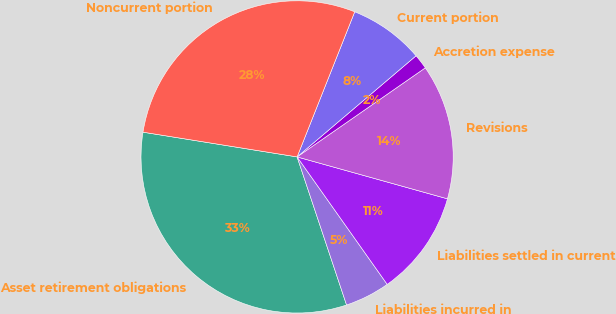Convert chart to OTSL. <chart><loc_0><loc_0><loc_500><loc_500><pie_chart><fcel>Asset retirement obligations<fcel>Liabilities incurred in<fcel>Liabilities settled in current<fcel>Revisions<fcel>Accretion expense<fcel>Current portion<fcel>Noncurrent portion<nl><fcel>32.66%<fcel>4.66%<fcel>10.88%<fcel>13.99%<fcel>1.55%<fcel>7.77%<fcel>28.48%<nl></chart> 